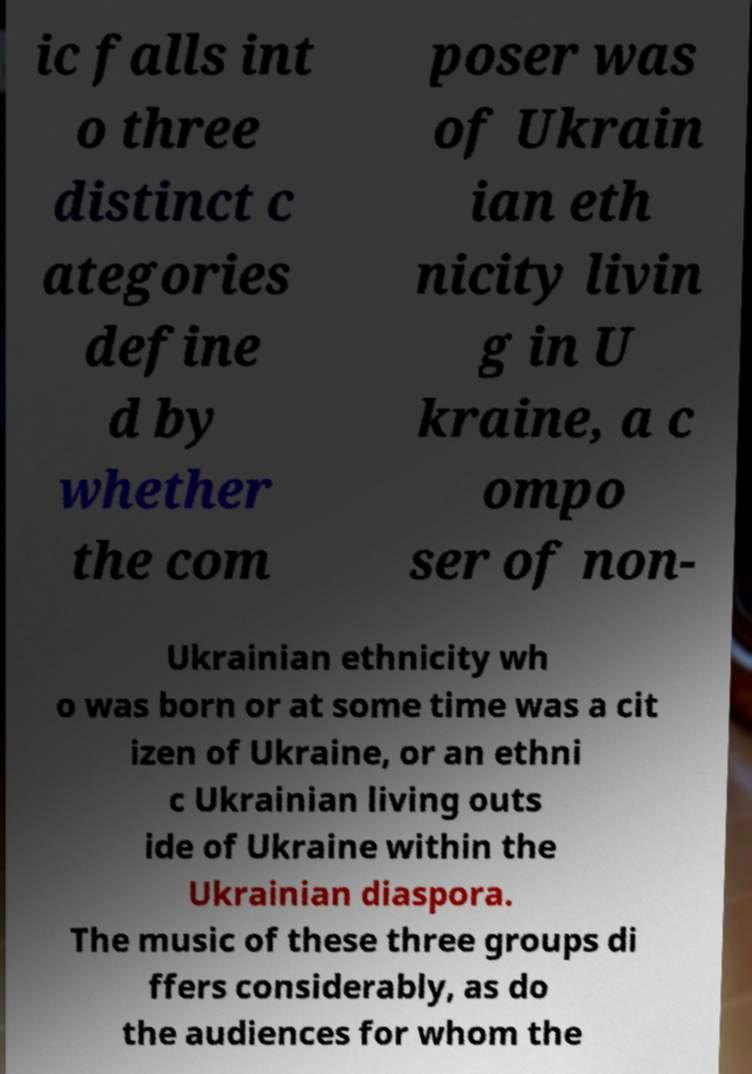Can you read and provide the text displayed in the image?This photo seems to have some interesting text. Can you extract and type it out for me? ic falls int o three distinct c ategories define d by whether the com poser was of Ukrain ian eth nicity livin g in U kraine, a c ompo ser of non- Ukrainian ethnicity wh o was born or at some time was a cit izen of Ukraine, or an ethni c Ukrainian living outs ide of Ukraine within the Ukrainian diaspora. The music of these three groups di ffers considerably, as do the audiences for whom the 